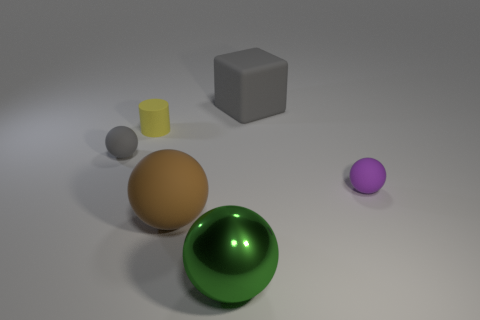What number of other objects are the same size as the gray matte sphere?
Your answer should be compact. 2. What is the size of the rubber ball that is in front of the tiny matte ball that is right of the brown rubber object?
Your response must be concise. Large. What number of large things are yellow cylinders or cyan balls?
Your answer should be compact. 0. What size is the gray thing that is right of the ball to the left of the big ball that is on the left side of the big green shiny object?
Give a very brief answer. Large. Are there any other things that are the same color as the big shiny ball?
Keep it short and to the point. No. There is a tiny sphere right of the gray thing behind the small object to the left of the rubber cylinder; what is it made of?
Your answer should be compact. Rubber. Is the large green thing the same shape as the big gray rubber object?
Make the answer very short. No. Is there anything else that is the same material as the yellow object?
Provide a short and direct response. Yes. How many objects are both on the right side of the brown rubber sphere and in front of the tiny purple matte thing?
Make the answer very short. 1. The large rubber object that is behind the tiny ball that is to the right of the gray block is what color?
Provide a succinct answer. Gray. 